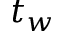Convert formula to latex. <formula><loc_0><loc_0><loc_500><loc_500>t _ { w }</formula> 